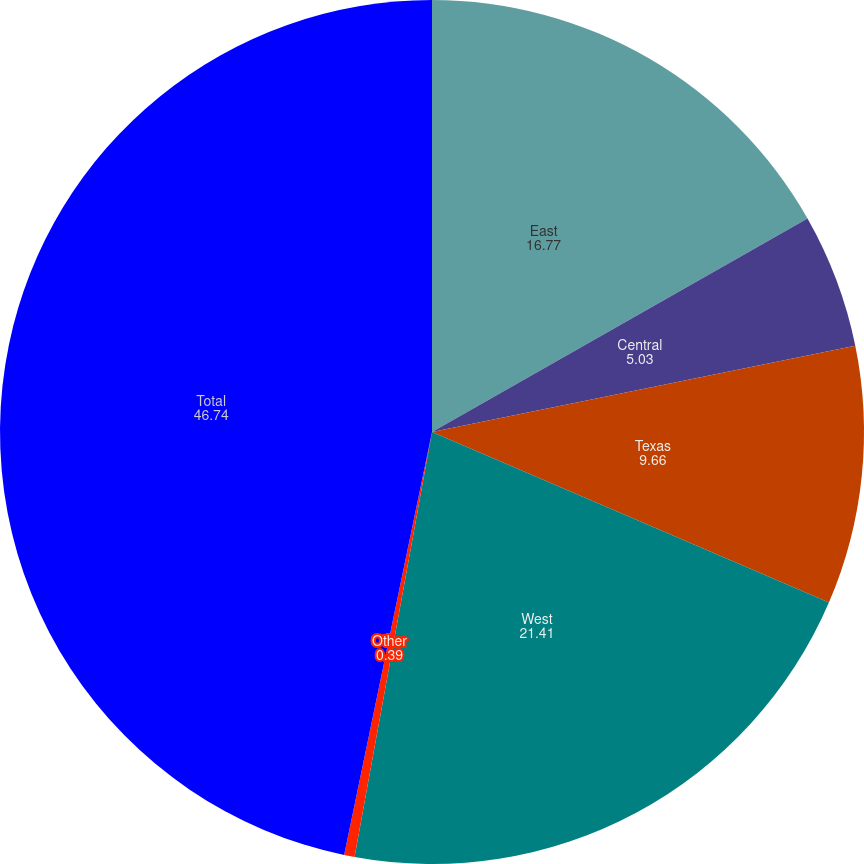Convert chart to OTSL. <chart><loc_0><loc_0><loc_500><loc_500><pie_chart><fcel>East<fcel>Central<fcel>Texas<fcel>West<fcel>Other<fcel>Total<nl><fcel>16.77%<fcel>5.03%<fcel>9.66%<fcel>21.41%<fcel>0.39%<fcel>46.74%<nl></chart> 